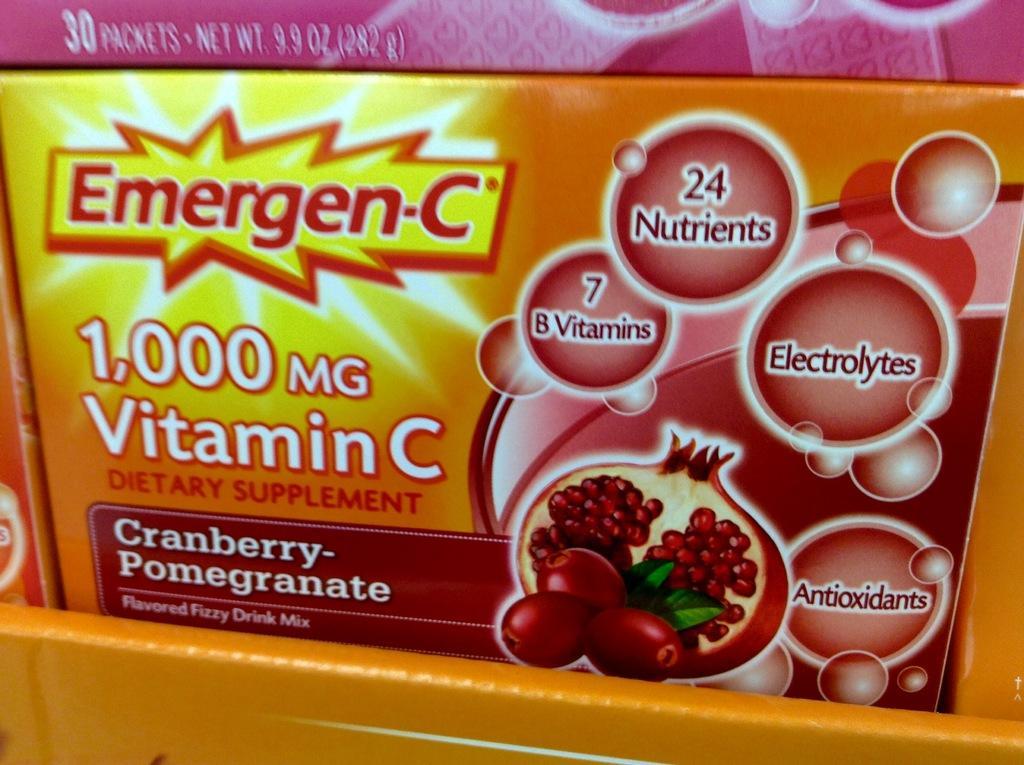Describe this image in one or two sentences. In this image we can see the boxes, on the boxes, we can see some text and images. 